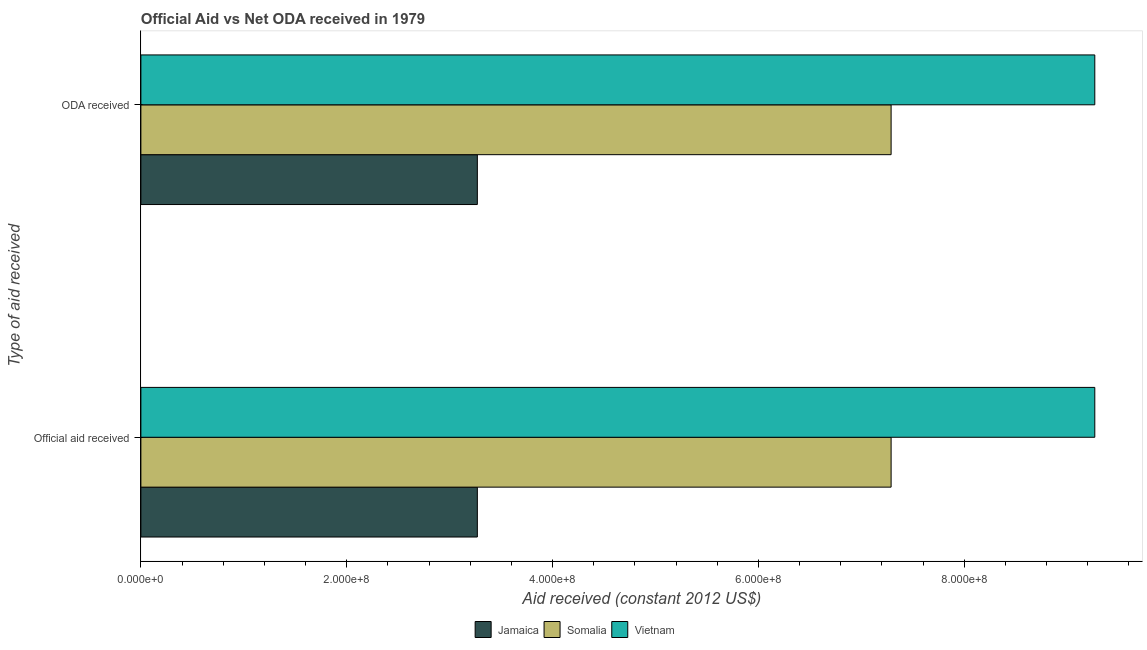Are the number of bars per tick equal to the number of legend labels?
Give a very brief answer. Yes. Are the number of bars on each tick of the Y-axis equal?
Offer a terse response. Yes. How many bars are there on the 1st tick from the bottom?
Ensure brevity in your answer.  3. What is the label of the 2nd group of bars from the top?
Ensure brevity in your answer.  Official aid received. What is the oda received in Somalia?
Make the answer very short. 7.29e+08. Across all countries, what is the maximum oda received?
Make the answer very short. 9.27e+08. Across all countries, what is the minimum oda received?
Offer a very short reply. 3.27e+08. In which country was the official aid received maximum?
Provide a short and direct response. Vietnam. In which country was the oda received minimum?
Ensure brevity in your answer.  Jamaica. What is the total oda received in the graph?
Keep it short and to the point. 1.98e+09. What is the difference between the oda received in Vietnam and that in Somalia?
Offer a terse response. 1.98e+08. What is the difference between the official aid received in Vietnam and the oda received in Jamaica?
Ensure brevity in your answer.  6.00e+08. What is the average official aid received per country?
Your answer should be very brief. 6.61e+08. What is the difference between the oda received and official aid received in Somalia?
Offer a terse response. 0. In how many countries, is the official aid received greater than 640000000 US$?
Give a very brief answer. 2. What is the ratio of the official aid received in Somalia to that in Jamaica?
Ensure brevity in your answer.  2.23. Is the official aid received in Vietnam less than that in Jamaica?
Provide a short and direct response. No. In how many countries, is the oda received greater than the average oda received taken over all countries?
Your response must be concise. 2. What does the 1st bar from the top in Official aid received represents?
Keep it short and to the point. Vietnam. What does the 2nd bar from the bottom in ODA received represents?
Ensure brevity in your answer.  Somalia. Are all the bars in the graph horizontal?
Offer a very short reply. Yes. How many countries are there in the graph?
Your response must be concise. 3. What is the difference between two consecutive major ticks on the X-axis?
Offer a terse response. 2.00e+08. How many legend labels are there?
Ensure brevity in your answer.  3. How are the legend labels stacked?
Keep it short and to the point. Horizontal. What is the title of the graph?
Your answer should be very brief. Official Aid vs Net ODA received in 1979 . Does "Latin America(all income levels)" appear as one of the legend labels in the graph?
Your response must be concise. No. What is the label or title of the X-axis?
Give a very brief answer. Aid received (constant 2012 US$). What is the label or title of the Y-axis?
Provide a short and direct response. Type of aid received. What is the Aid received (constant 2012 US$) in Jamaica in Official aid received?
Provide a short and direct response. 3.27e+08. What is the Aid received (constant 2012 US$) of Somalia in Official aid received?
Your answer should be compact. 7.29e+08. What is the Aid received (constant 2012 US$) in Vietnam in Official aid received?
Offer a very short reply. 9.27e+08. What is the Aid received (constant 2012 US$) in Jamaica in ODA received?
Provide a succinct answer. 3.27e+08. What is the Aid received (constant 2012 US$) in Somalia in ODA received?
Your answer should be very brief. 7.29e+08. What is the Aid received (constant 2012 US$) of Vietnam in ODA received?
Your answer should be very brief. 9.27e+08. Across all Type of aid received, what is the maximum Aid received (constant 2012 US$) of Jamaica?
Your answer should be very brief. 3.27e+08. Across all Type of aid received, what is the maximum Aid received (constant 2012 US$) in Somalia?
Offer a very short reply. 7.29e+08. Across all Type of aid received, what is the maximum Aid received (constant 2012 US$) in Vietnam?
Your response must be concise. 9.27e+08. Across all Type of aid received, what is the minimum Aid received (constant 2012 US$) of Jamaica?
Give a very brief answer. 3.27e+08. Across all Type of aid received, what is the minimum Aid received (constant 2012 US$) in Somalia?
Ensure brevity in your answer.  7.29e+08. Across all Type of aid received, what is the minimum Aid received (constant 2012 US$) of Vietnam?
Your answer should be compact. 9.27e+08. What is the total Aid received (constant 2012 US$) in Jamaica in the graph?
Make the answer very short. 6.54e+08. What is the total Aid received (constant 2012 US$) in Somalia in the graph?
Keep it short and to the point. 1.46e+09. What is the total Aid received (constant 2012 US$) in Vietnam in the graph?
Offer a terse response. 1.85e+09. What is the difference between the Aid received (constant 2012 US$) of Jamaica in Official aid received and that in ODA received?
Make the answer very short. 0. What is the difference between the Aid received (constant 2012 US$) in Somalia in Official aid received and that in ODA received?
Offer a terse response. 0. What is the difference between the Aid received (constant 2012 US$) of Jamaica in Official aid received and the Aid received (constant 2012 US$) of Somalia in ODA received?
Keep it short and to the point. -4.02e+08. What is the difference between the Aid received (constant 2012 US$) of Jamaica in Official aid received and the Aid received (constant 2012 US$) of Vietnam in ODA received?
Keep it short and to the point. -6.00e+08. What is the difference between the Aid received (constant 2012 US$) of Somalia in Official aid received and the Aid received (constant 2012 US$) of Vietnam in ODA received?
Your response must be concise. -1.98e+08. What is the average Aid received (constant 2012 US$) in Jamaica per Type of aid received?
Offer a very short reply. 3.27e+08. What is the average Aid received (constant 2012 US$) of Somalia per Type of aid received?
Offer a terse response. 7.29e+08. What is the average Aid received (constant 2012 US$) of Vietnam per Type of aid received?
Make the answer very short. 9.27e+08. What is the difference between the Aid received (constant 2012 US$) of Jamaica and Aid received (constant 2012 US$) of Somalia in Official aid received?
Your answer should be very brief. -4.02e+08. What is the difference between the Aid received (constant 2012 US$) of Jamaica and Aid received (constant 2012 US$) of Vietnam in Official aid received?
Keep it short and to the point. -6.00e+08. What is the difference between the Aid received (constant 2012 US$) in Somalia and Aid received (constant 2012 US$) in Vietnam in Official aid received?
Ensure brevity in your answer.  -1.98e+08. What is the difference between the Aid received (constant 2012 US$) of Jamaica and Aid received (constant 2012 US$) of Somalia in ODA received?
Give a very brief answer. -4.02e+08. What is the difference between the Aid received (constant 2012 US$) in Jamaica and Aid received (constant 2012 US$) in Vietnam in ODA received?
Provide a short and direct response. -6.00e+08. What is the difference between the Aid received (constant 2012 US$) in Somalia and Aid received (constant 2012 US$) in Vietnam in ODA received?
Your answer should be compact. -1.98e+08. What is the ratio of the Aid received (constant 2012 US$) of Somalia in Official aid received to that in ODA received?
Keep it short and to the point. 1. What is the difference between the highest and the second highest Aid received (constant 2012 US$) of Jamaica?
Offer a terse response. 0. What is the difference between the highest and the second highest Aid received (constant 2012 US$) of Somalia?
Your response must be concise. 0. What is the difference between the highest and the second highest Aid received (constant 2012 US$) of Vietnam?
Your answer should be compact. 0. What is the difference between the highest and the lowest Aid received (constant 2012 US$) of Jamaica?
Make the answer very short. 0. 